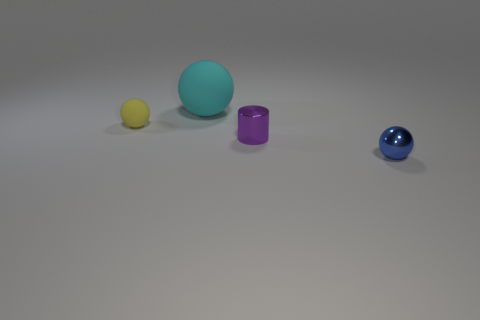There is another object that is the same material as the cyan object; what is its shape?
Keep it short and to the point. Sphere. There is a matte object behind the small sphere left of the metallic thing on the left side of the tiny blue thing; what shape is it?
Your response must be concise. Sphere. Are there more small cyan rubber cubes than cyan balls?
Your response must be concise. No. There is a blue thing that is the same shape as the large cyan object; what is its material?
Keep it short and to the point. Metal. Are the small yellow ball and the purple thing made of the same material?
Give a very brief answer. No. Is the number of matte balls in front of the metallic cylinder greater than the number of large cyan matte spheres?
Your response must be concise. No. What is the material of the small ball that is left of the metallic thing in front of the small purple object behind the metallic ball?
Give a very brief answer. Rubber. What number of objects are small rubber things or shiny things behind the blue thing?
Your response must be concise. 2. Do the ball right of the big cyan matte object and the big ball have the same color?
Keep it short and to the point. No. Are there more big matte objects that are in front of the purple cylinder than rubber spheres that are to the right of the small rubber ball?
Keep it short and to the point. No. 